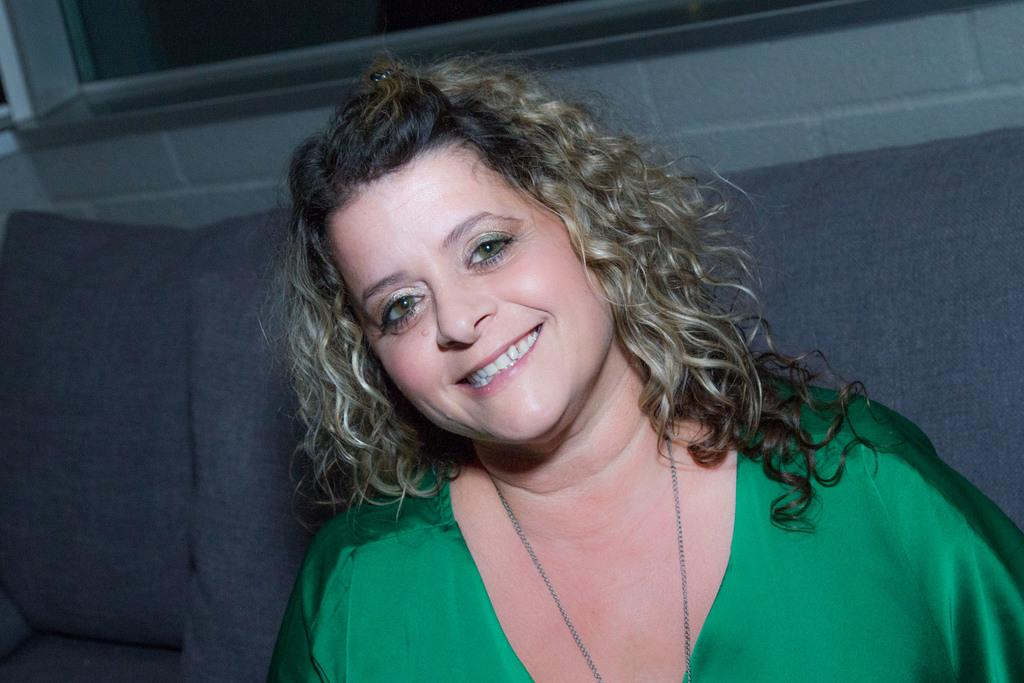Who is present in the image? There is a woman in the image. What is the woman wearing? The woman is wearing a green top. What expression does the woman have? The woman is smiling. What can be seen in the background of the image? There is a sofa, a window, and a wall in the background of the image. What type of pies can be seen on the table in the image? There is no table or pies present in the image. 